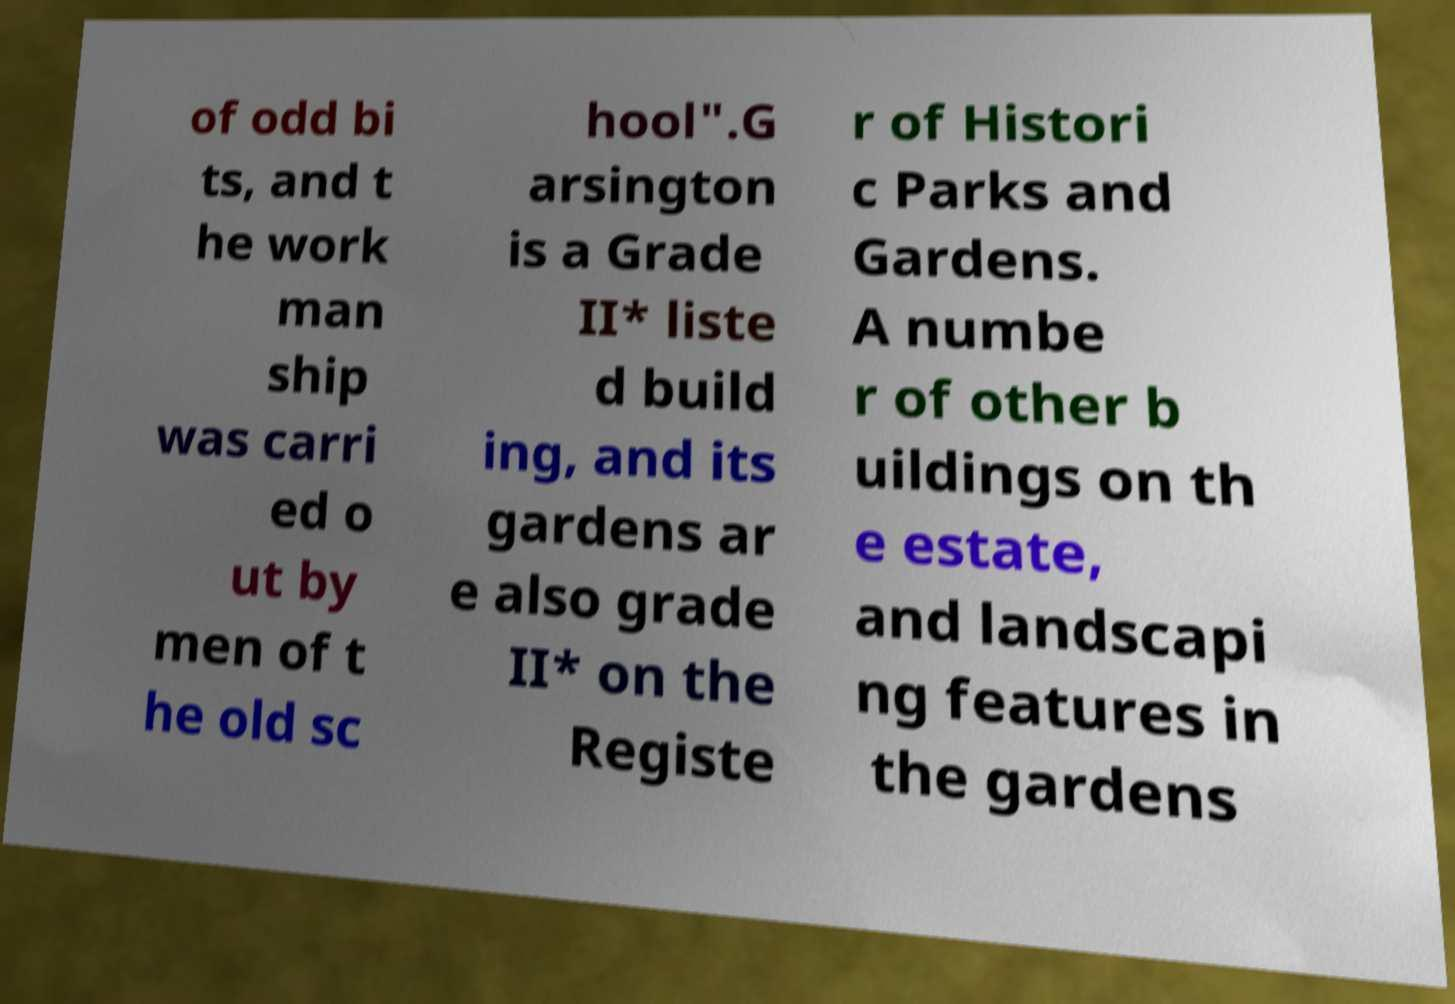Please read and relay the text visible in this image. What does it say? of odd bi ts, and t he work man ship was carri ed o ut by men of t he old sc hool".G arsington is a Grade II* liste d build ing, and its gardens ar e also grade II* on the Registe r of Histori c Parks and Gardens. A numbe r of other b uildings on th e estate, and landscapi ng features in the gardens 